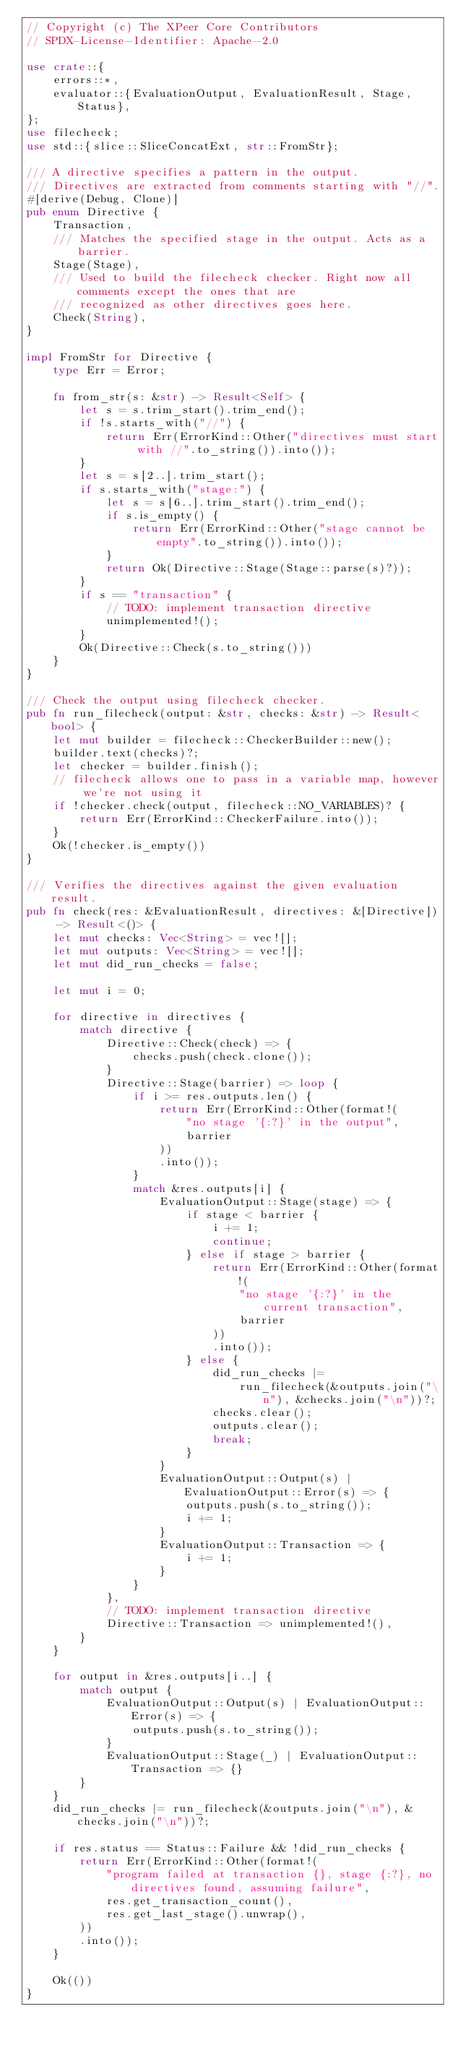Convert code to text. <code><loc_0><loc_0><loc_500><loc_500><_Rust_>// Copyright (c) The XPeer Core Contributors
// SPDX-License-Identifier: Apache-2.0

use crate::{
    errors::*,
    evaluator::{EvaluationOutput, EvaluationResult, Stage, Status},
};
use filecheck;
use std::{slice::SliceConcatExt, str::FromStr};

/// A directive specifies a pattern in the output.
/// Directives are extracted from comments starting with "//".
#[derive(Debug, Clone)]
pub enum Directive {
    Transaction,
    /// Matches the specified stage in the output. Acts as a barrier.
    Stage(Stage),
    /// Used to build the filecheck checker. Right now all comments except the ones that are
    /// recognized as other directives goes here.
    Check(String),
}

impl FromStr for Directive {
    type Err = Error;

    fn from_str(s: &str) -> Result<Self> {
        let s = s.trim_start().trim_end();
        if !s.starts_with("//") {
            return Err(ErrorKind::Other("directives must start with //".to_string()).into());
        }
        let s = s[2..].trim_start();
        if s.starts_with("stage:") {
            let s = s[6..].trim_start().trim_end();
            if s.is_empty() {
                return Err(ErrorKind::Other("stage cannot be empty".to_string()).into());
            }
            return Ok(Directive::Stage(Stage::parse(s)?));
        }
        if s == "transaction" {
            // TODO: implement transaction directive
            unimplemented!();
        }
        Ok(Directive::Check(s.to_string()))
    }
}

/// Check the output using filecheck checker.
pub fn run_filecheck(output: &str, checks: &str) -> Result<bool> {
    let mut builder = filecheck::CheckerBuilder::new();
    builder.text(checks)?;
    let checker = builder.finish();
    // filecheck allows one to pass in a variable map, however we're not using it
    if !checker.check(output, filecheck::NO_VARIABLES)? {
        return Err(ErrorKind::CheckerFailure.into());
    }
    Ok(!checker.is_empty())
}

/// Verifies the directives against the given evaluation result.
pub fn check(res: &EvaluationResult, directives: &[Directive]) -> Result<()> {
    let mut checks: Vec<String> = vec![];
    let mut outputs: Vec<String> = vec![];
    let mut did_run_checks = false;

    let mut i = 0;

    for directive in directives {
        match directive {
            Directive::Check(check) => {
                checks.push(check.clone());
            }
            Directive::Stage(barrier) => loop {
                if i >= res.outputs.len() {
                    return Err(ErrorKind::Other(format!(
                        "no stage '{:?}' in the output",
                        barrier
                    ))
                    .into());
                }
                match &res.outputs[i] {
                    EvaluationOutput::Stage(stage) => {
                        if stage < barrier {
                            i += 1;
                            continue;
                        } else if stage > barrier {
                            return Err(ErrorKind::Other(format!(
                                "no stage '{:?}' in the current transaction",
                                barrier
                            ))
                            .into());
                        } else {
                            did_run_checks |=
                                run_filecheck(&outputs.join("\n"), &checks.join("\n"))?;
                            checks.clear();
                            outputs.clear();
                            break;
                        }
                    }
                    EvaluationOutput::Output(s) | EvaluationOutput::Error(s) => {
                        outputs.push(s.to_string());
                        i += 1;
                    }
                    EvaluationOutput::Transaction => {
                        i += 1;
                    }
                }
            },
            // TODO: implement transaction directive
            Directive::Transaction => unimplemented!(),
        }
    }

    for output in &res.outputs[i..] {
        match output {
            EvaluationOutput::Output(s) | EvaluationOutput::Error(s) => {
                outputs.push(s.to_string());
            }
            EvaluationOutput::Stage(_) | EvaluationOutput::Transaction => {}
        }
    }
    did_run_checks |= run_filecheck(&outputs.join("\n"), &checks.join("\n"))?;

    if res.status == Status::Failure && !did_run_checks {
        return Err(ErrorKind::Other(format!(
            "program failed at transaction {}, stage {:?}, no directives found, assuming failure",
            res.get_transaction_count(),
            res.get_last_stage().unwrap(),
        ))
        .into());
    }

    Ok(())
}
</code> 